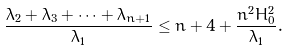<formula> <loc_0><loc_0><loc_500><loc_500>\frac { \lambda _ { 2 } + \lambda _ { 3 } + \cdots + \lambda _ { n + 1 } } { \lambda _ { 1 } } \leq n + 4 + \frac { n ^ { 2 } H _ { 0 } ^ { 2 } } { \lambda _ { 1 } } .</formula> 